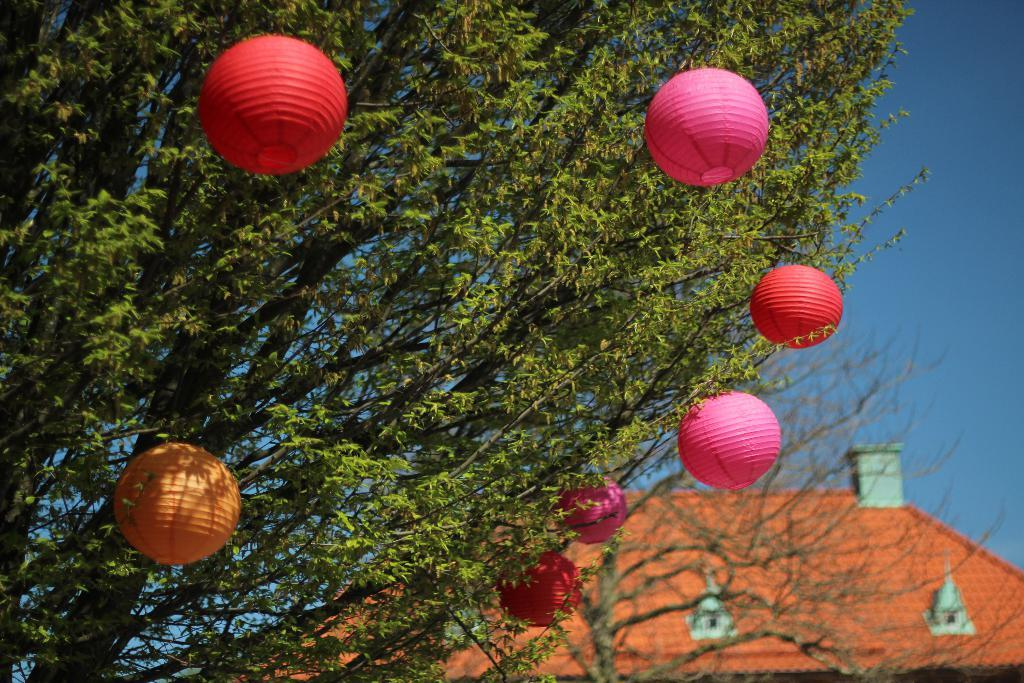What type of structure is visible in the image? There is a building in the image. What can be seen on the top of the building? There are roof tiles on the top of the building. What type of vegetation is present in the image? There is a tree in the image. What is on the tree? There are objects on the tree. What is visible at the top of the image? The sky is visible at the top of the image. What type of butter is being spread on the tree in the image? There is no butter present in the image, and the tree does not have any spread on it. 